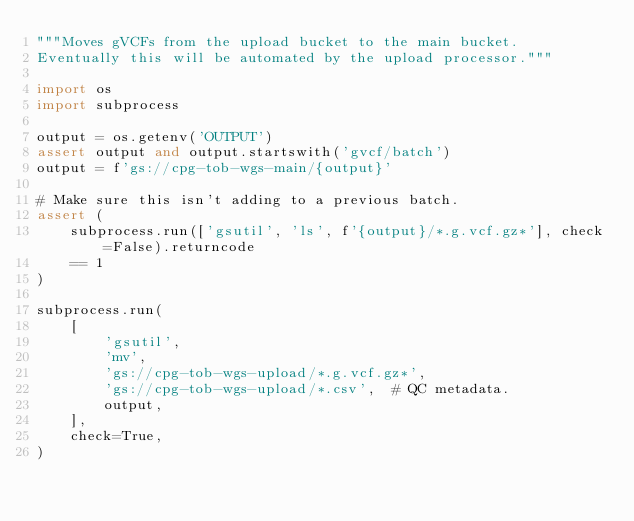<code> <loc_0><loc_0><loc_500><loc_500><_Python_>"""Moves gVCFs from the upload bucket to the main bucket.
Eventually this will be automated by the upload processor."""

import os
import subprocess

output = os.getenv('OUTPUT')
assert output and output.startswith('gvcf/batch')
output = f'gs://cpg-tob-wgs-main/{output}'

# Make sure this isn't adding to a previous batch.
assert (
    subprocess.run(['gsutil', 'ls', f'{output}/*.g.vcf.gz*'], check=False).returncode
    == 1
)

subprocess.run(
    [
        'gsutil',
        'mv',
        'gs://cpg-tob-wgs-upload/*.g.vcf.gz*',
        'gs://cpg-tob-wgs-upload/*.csv',  # QC metadata.
        output,
    ],
    check=True,
)
</code> 